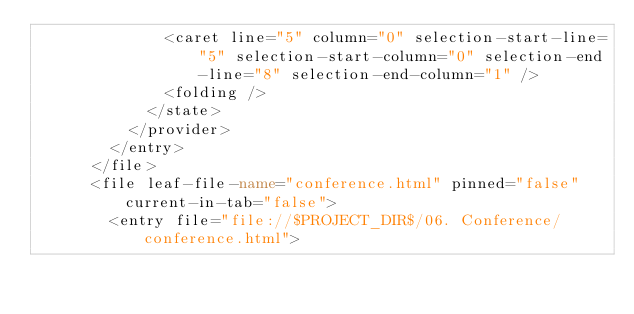Convert code to text. <code><loc_0><loc_0><loc_500><loc_500><_XML_>              <caret line="5" column="0" selection-start-line="5" selection-start-column="0" selection-end-line="8" selection-end-column="1" />
              <folding />
            </state>
          </provider>
        </entry>
      </file>
      <file leaf-file-name="conference.html" pinned="false" current-in-tab="false">
        <entry file="file://$PROJECT_DIR$/06. Conference/conference.html"></code> 